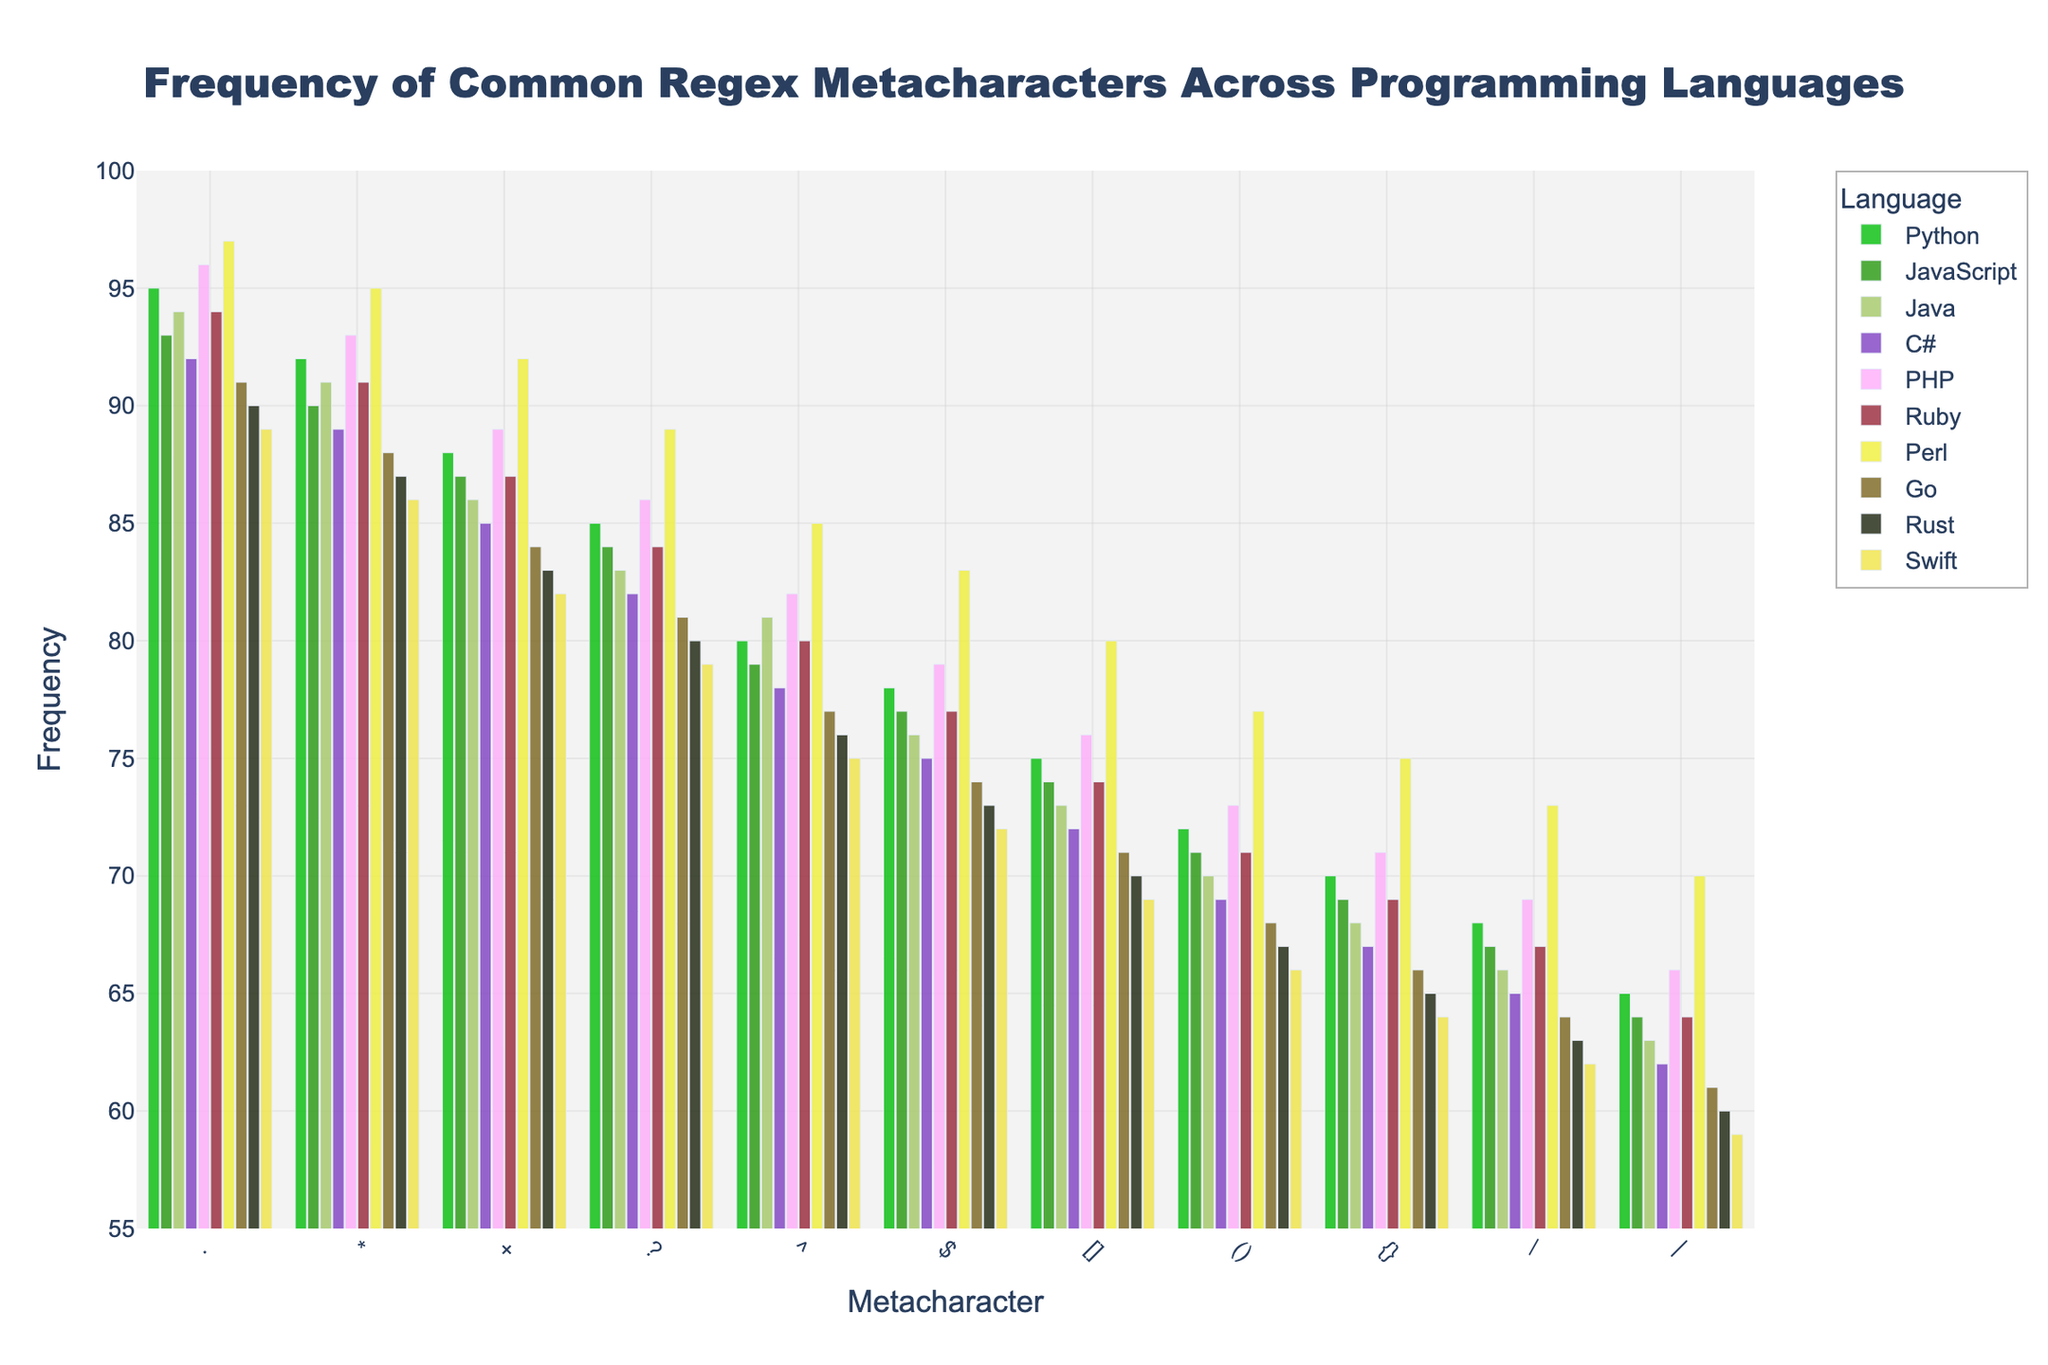What metacharacter is the most frequently used in all the programming languages? To determine the most frequently used metacharacter, we need to compare the heights of the bars for all metacharacters across all programming languages. The "." metacharacter has the highest frequency across nearly all languages.
Answer: "." Which programming language uses the "+" metacharacter the least frequently? We locate the bar labeled "+" for each programming language and find the shortest bar. Swift shows the least frequency for the "+" metacharacter.
Answer: Swift Compare the usage frequency of the "?" metacharacter between Python and Perl. Which language uses it more frequently and by how much? Look at the heights of the bars for the "?" metacharacter for Python and Perl. Python’s bar is at 85 and Perl’s is at 89. The difference is 89 - 85 = 4, meaning Perl uses it more frequently by 4 units.
Answer: Perl, by 4 units Calculate the average frequency of the "^" and "$" metacharacters in JavaScript. Add the frequencies of the "^" and "$" metacharacters in JavaScript (79 and 77) and divide by 2. The average is (79 + 77) / 2 = 78.
Answer: 78 For the C# language, which metacharacter is used significantly more than the others? Observe the height of C# bars; higher bars indicate more frequent metacharacter usage. The "." metacharacter at 92 is used significantly more in C# compared to other metacharacters.
Answer: "." What is the total frequency of the "()" metacharacter usage across Python, Java, and PHP? Add the frequencies of the "()" metacharacter for Python (72), Java (70), and PHP (73). The total is 72 + 70 + 73 = 215.
Answer: 215 Which programming languages have the exact same frequency for the "[]" metacharacter, and what is that frequency? Compare the frequency bar for the "[]" metacharacter for each language. Python, JavaScript, and Ruby all have the "[]" frequency at 75.
Answer: Python, JavaScript, and Ruby; 75 What is the trend in the usage of "\" metacharacter from Python to Swift? Visually analyze the heights of the bars for the "\" metacharacter from Python to Swift. The frequencies decrease gradually from Python (68), JavaScript (67), Java (66), C# (65), PHP (69), Ruby (67), Perl (73), Go (64), Rust (63), to Swift (62).
Answer: Decreasing 